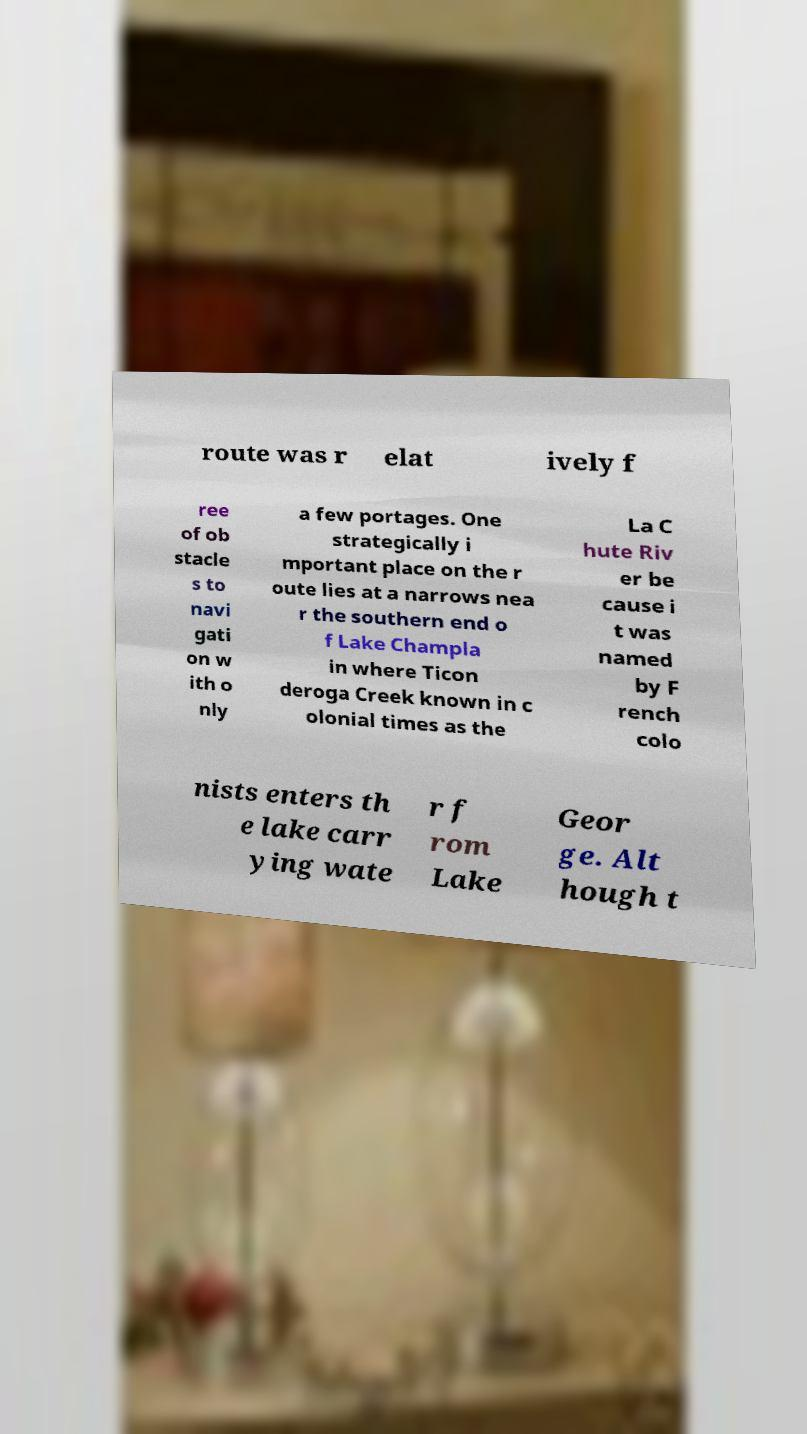Could you extract and type out the text from this image? route was r elat ively f ree of ob stacle s to navi gati on w ith o nly a few portages. One strategically i mportant place on the r oute lies at a narrows nea r the southern end o f Lake Champla in where Ticon deroga Creek known in c olonial times as the La C hute Riv er be cause i t was named by F rench colo nists enters th e lake carr ying wate r f rom Lake Geor ge. Alt hough t 